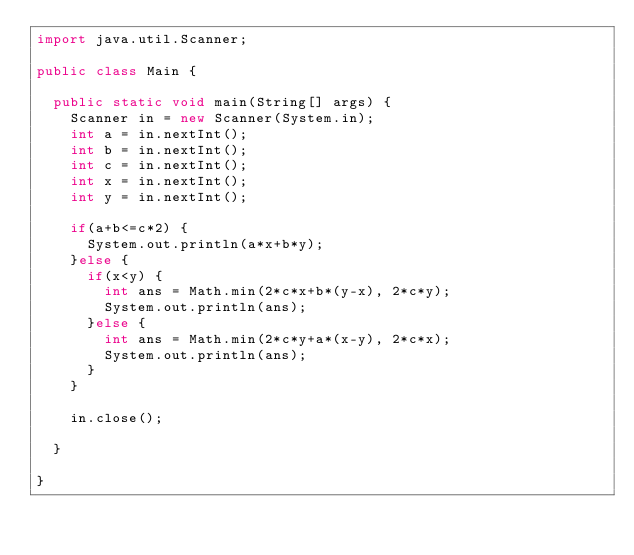<code> <loc_0><loc_0><loc_500><loc_500><_Java_>import java.util.Scanner;

public class Main {

	public static void main(String[] args) {
		Scanner in = new Scanner(System.in);
		int a = in.nextInt();
		int b = in.nextInt();
		int c = in.nextInt();
		int x = in.nextInt();
		int y = in.nextInt();
		
		if(a+b<=c*2) {
			System.out.println(a*x+b*y);
		}else {
			if(x<y) {
				int ans = Math.min(2*c*x+b*(y-x), 2*c*y);
				System.out.println(ans);
			}else {
				int ans = Math.min(2*c*y+a*(x-y), 2*c*x);
				System.out.println(ans);
			}
		}
		
		in.close();

	}

}
</code> 